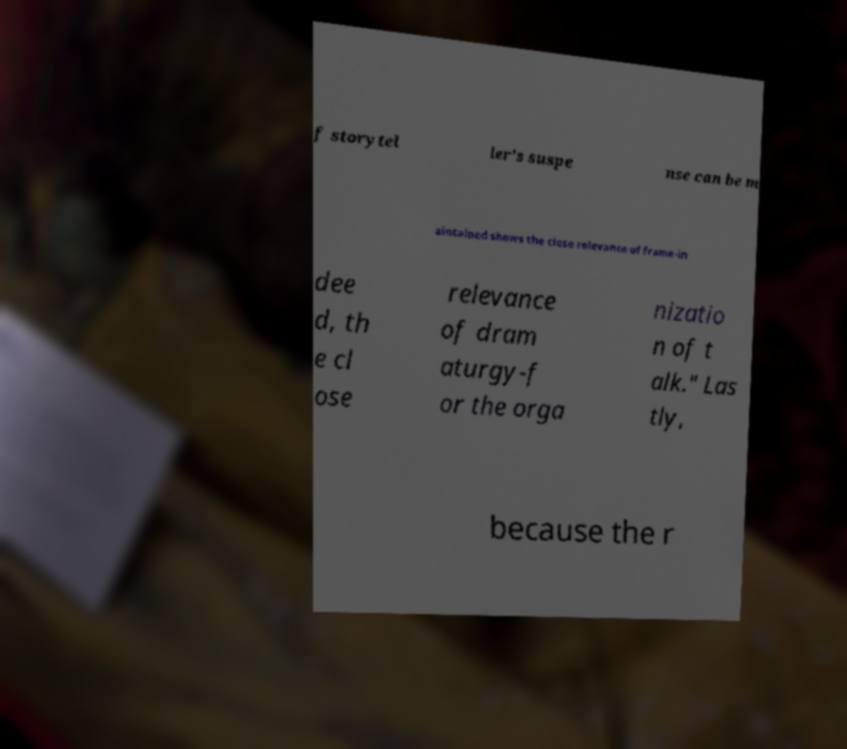Can you accurately transcribe the text from the provided image for me? f storytel ler's suspe nse can be m aintained shows the close relevance of frame-in dee d, th e cl ose relevance of dram aturgy-f or the orga nizatio n of t alk." Las tly, because the r 